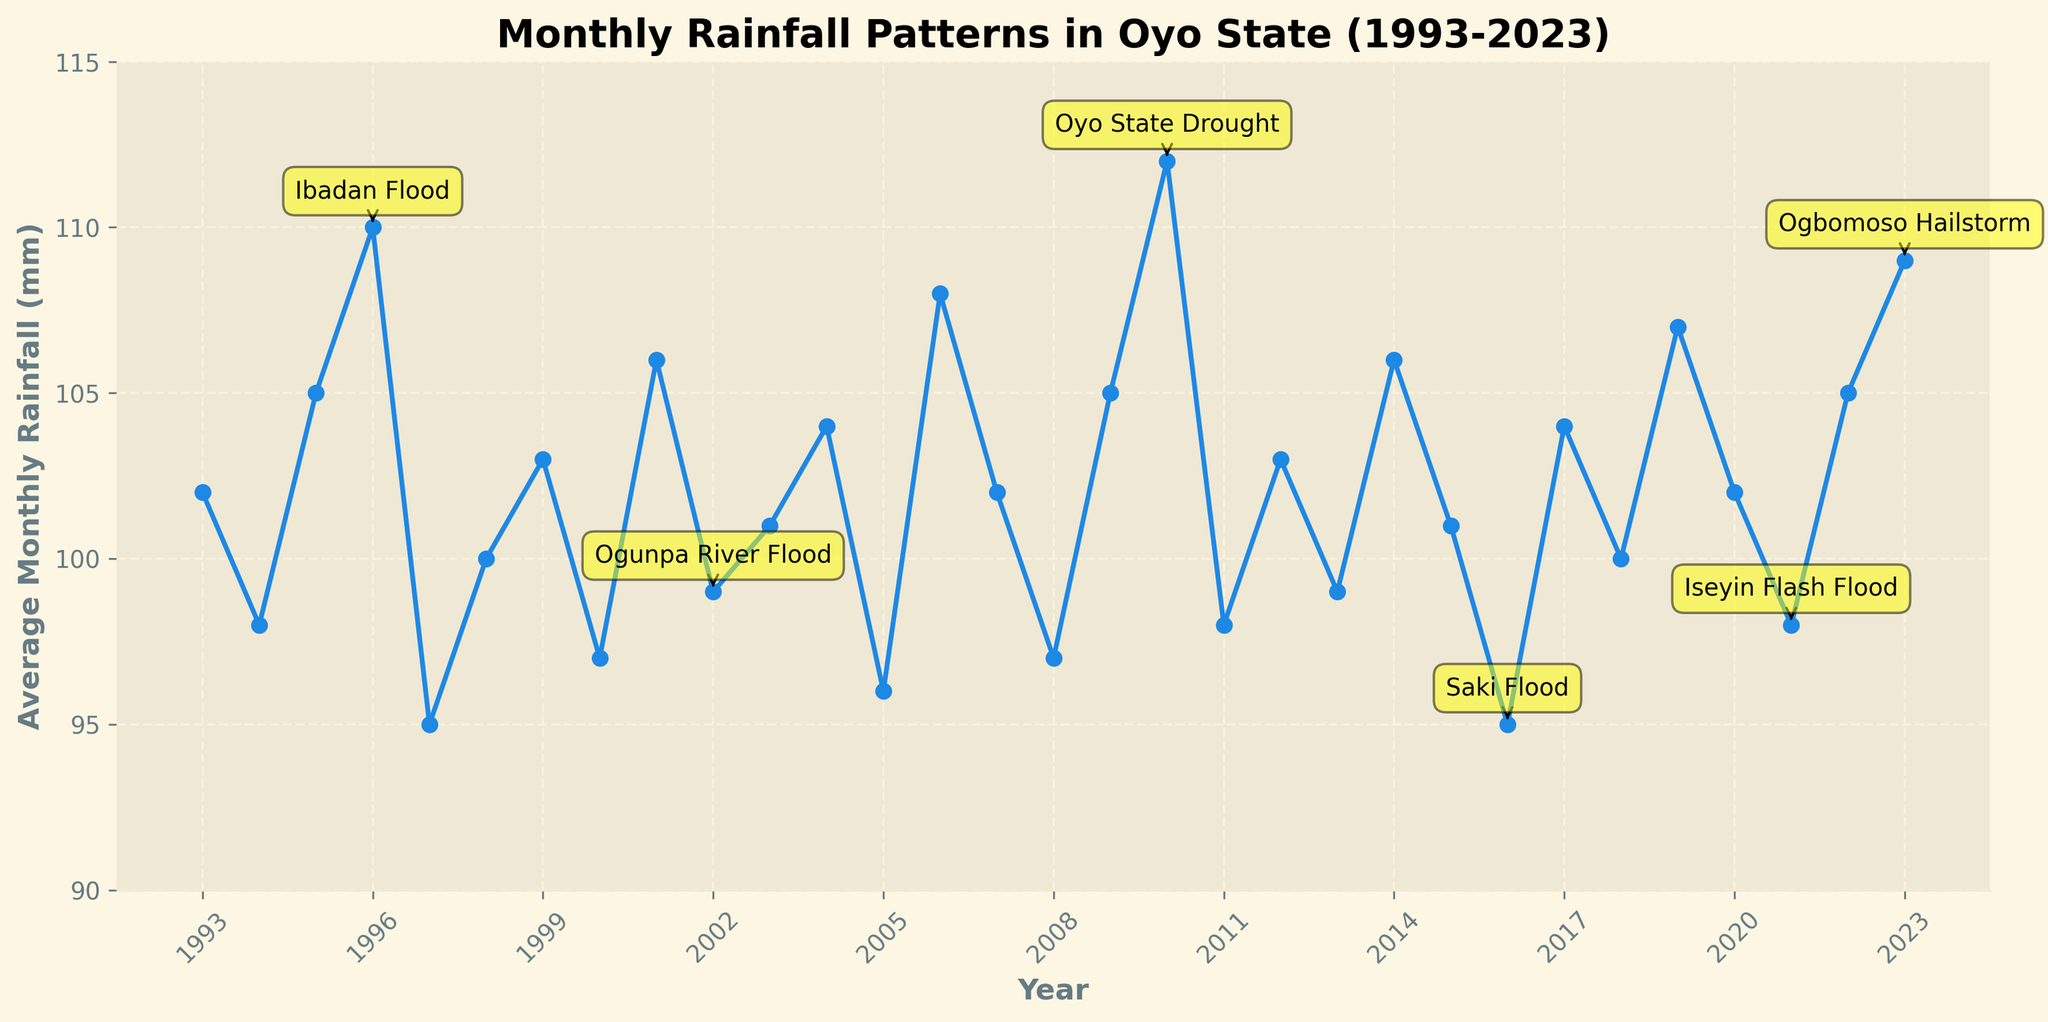What is the average monthly rainfall for the years with extreme weather events? The years with extreme weather events are 1996, 2002, 2010, 2016, 2021, and 2023. The respective average monthly rainfalls are 110, 99, 112, 95, 98, and 109 mm. To find the average, sum these values (110 + 99 + 112 + 95 + 98 + 109 = 623) and divide by the number of events (6). 623 / 6 ≈ 103.83 mm
Answer: 103.83 mm Which year had the highest and which had the lowest average monthly rainfall? The line chart shows the rainfall over the years; the peak is at 2010 with 112 mm, and the lowest point is at 2016 with 95 mm.
Answer: Highest: 2010, Lowest: 2016 How did the average monthly rainfall in 2021 compare to the preceding year? In 2020, the rainfall was 102 mm, and in 2021, it was 98 mm. The rainfall decreased by 102 - 98 = 4 mm.
Answer: Decreased by 4 mm What is the trend of average monthly rainfall before and after the Ibadan Flood in 1996? Before the Ibadan Flood in 1996, rainfall was 105 mm in 1995 and 98 mm in 1994. After the flood, it was 95 mm in 1997 and 100 mm in 1998, showing a decrease and then a slight increase.
Answer: Decrease and slight increase What is the median average monthly rainfall over the 30 years? To find the median, first list all rainfall amounts in ascending order. The 15th and 16th numbers (middle two) in the list (97, 97, 98, 98, 98, 99, 99, 100, 100, 101, 101, 102, 102, 103, 103, 104, 104, 104, 105, 105, 105, 106, 106, 107, 108, 109, 110, 112) are both 104. The median is (104 + 104) / 2 = 104.
Answer: 104 mm How many extreme weather events occurred when the average monthly rainfall was above 105 mm? Refer to extreme weather years: 1996 (110 mm), 2010 (112 mm), and 2023 (109 mm). Count the events: three times.
Answer: 3 occurrences Which extreme weather event had the lowest average monthly rainfall associated with it? From the extreme weather events listed, Saki Flood in 2016 had the lowest rainfall of 95 mm.
Answer: Saki Flood, 95 mm Compare the frequency of rainfall totals between 95 mm and 105 mm to those above 105 mm. Counts: 95-105 mm: 1994, 1997, 1998, 2000, 2002, 2003, 2004, 2005, 2007, 2008, 2009, 2011, 2012, 2013, 2014, 2015, 2017, 2018, 2021, and 2022 (20 years). Above 105 mm: 1993, 1995, 1996, 2001, 2006, 2010, 2016, 2019, and 2023 (9 years).
Answer: 20 years vs. 9 years 